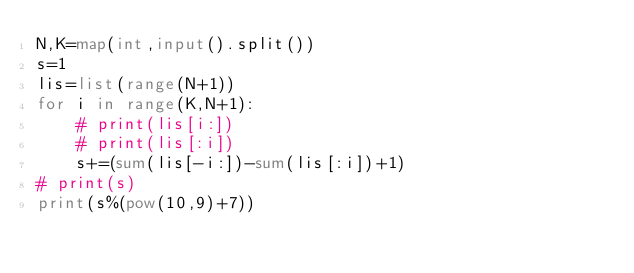Convert code to text. <code><loc_0><loc_0><loc_500><loc_500><_Python_>N,K=map(int,input().split())
s=1
lis=list(range(N+1))
for i in range(K,N+1):
    # print(lis[i:])
    # print(lis[:i])
    s+=(sum(lis[-i:])-sum(lis[:i])+1)
# print(s)
print(s%(pow(10,9)+7))</code> 